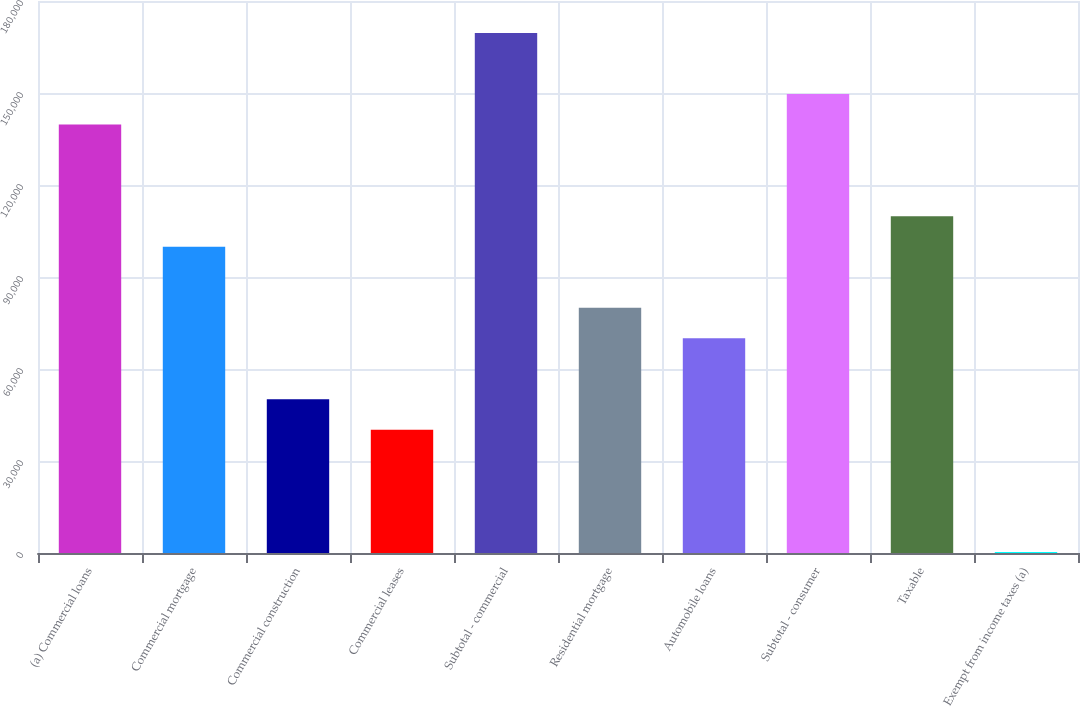Convert chart to OTSL. <chart><loc_0><loc_0><loc_500><loc_500><bar_chart><fcel>(a) Commercial loans<fcel>Commercial mortgage<fcel>Commercial construction<fcel>Commercial leases<fcel>Subtotal - commercial<fcel>Residential mortgage<fcel>Automobile loans<fcel>Subtotal - consumer<fcel>Taxable<fcel>Exempt from income taxes (a)<nl><fcel>139695<fcel>99880<fcel>50111<fcel>40157.2<fcel>169557<fcel>79972.4<fcel>70018.6<fcel>149649<fcel>109834<fcel>342<nl></chart> 